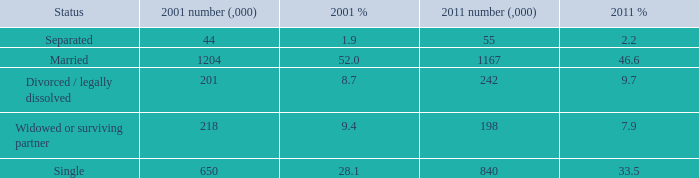Would you mind parsing the complete table? {'header': ['Status', '2001 number (,000)', '2001 %', '2011 number (,000)', '2011 %'], 'rows': [['Separated', '44', '1.9', '55', '2.2'], ['Married', '1204', '52.0', '1167', '46.6'], ['Divorced / legally dissolved', '201', '8.7', '242', '9.7'], ['Widowed or surviving partner', '218', '9.4', '198', '7.9'], ['Single', '650', '28.1', '840', '33.5']]} How many 2011 % is 7.9? 1.0. 